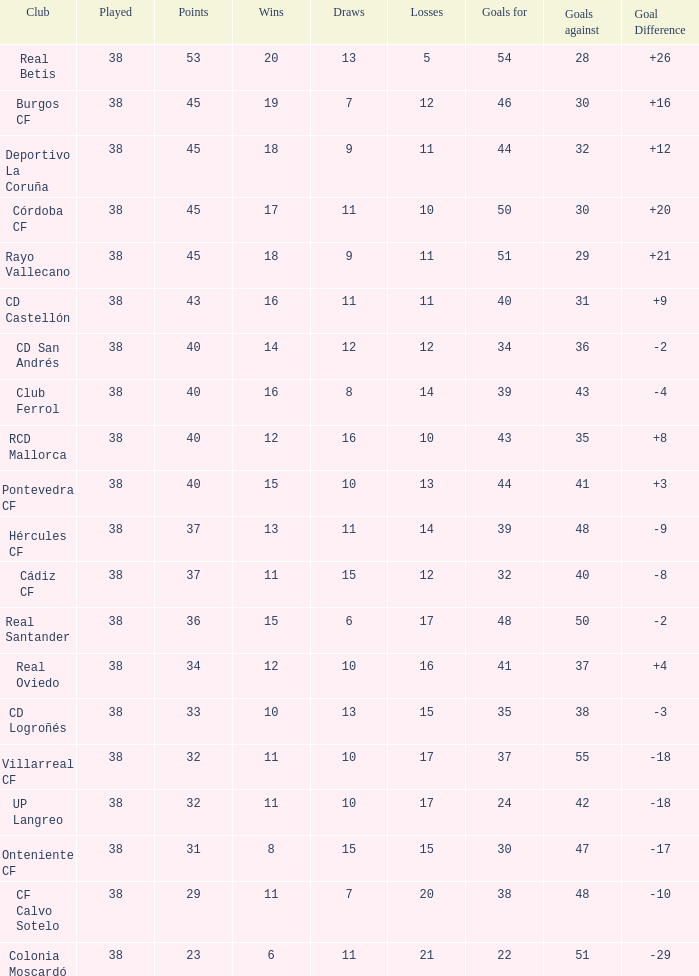What is the maximum number of goals conceded by pontevedra cf when they have played fewer than 38 matches? None. 